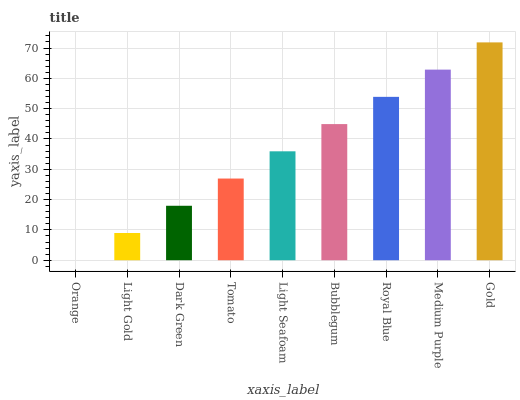Is Orange the minimum?
Answer yes or no. Yes. Is Gold the maximum?
Answer yes or no. Yes. Is Light Gold the minimum?
Answer yes or no. No. Is Light Gold the maximum?
Answer yes or no. No. Is Light Gold greater than Orange?
Answer yes or no. Yes. Is Orange less than Light Gold?
Answer yes or no. Yes. Is Orange greater than Light Gold?
Answer yes or no. No. Is Light Gold less than Orange?
Answer yes or no. No. Is Light Seafoam the high median?
Answer yes or no. Yes. Is Light Seafoam the low median?
Answer yes or no. Yes. Is Royal Blue the high median?
Answer yes or no. No. Is Bubblegum the low median?
Answer yes or no. No. 